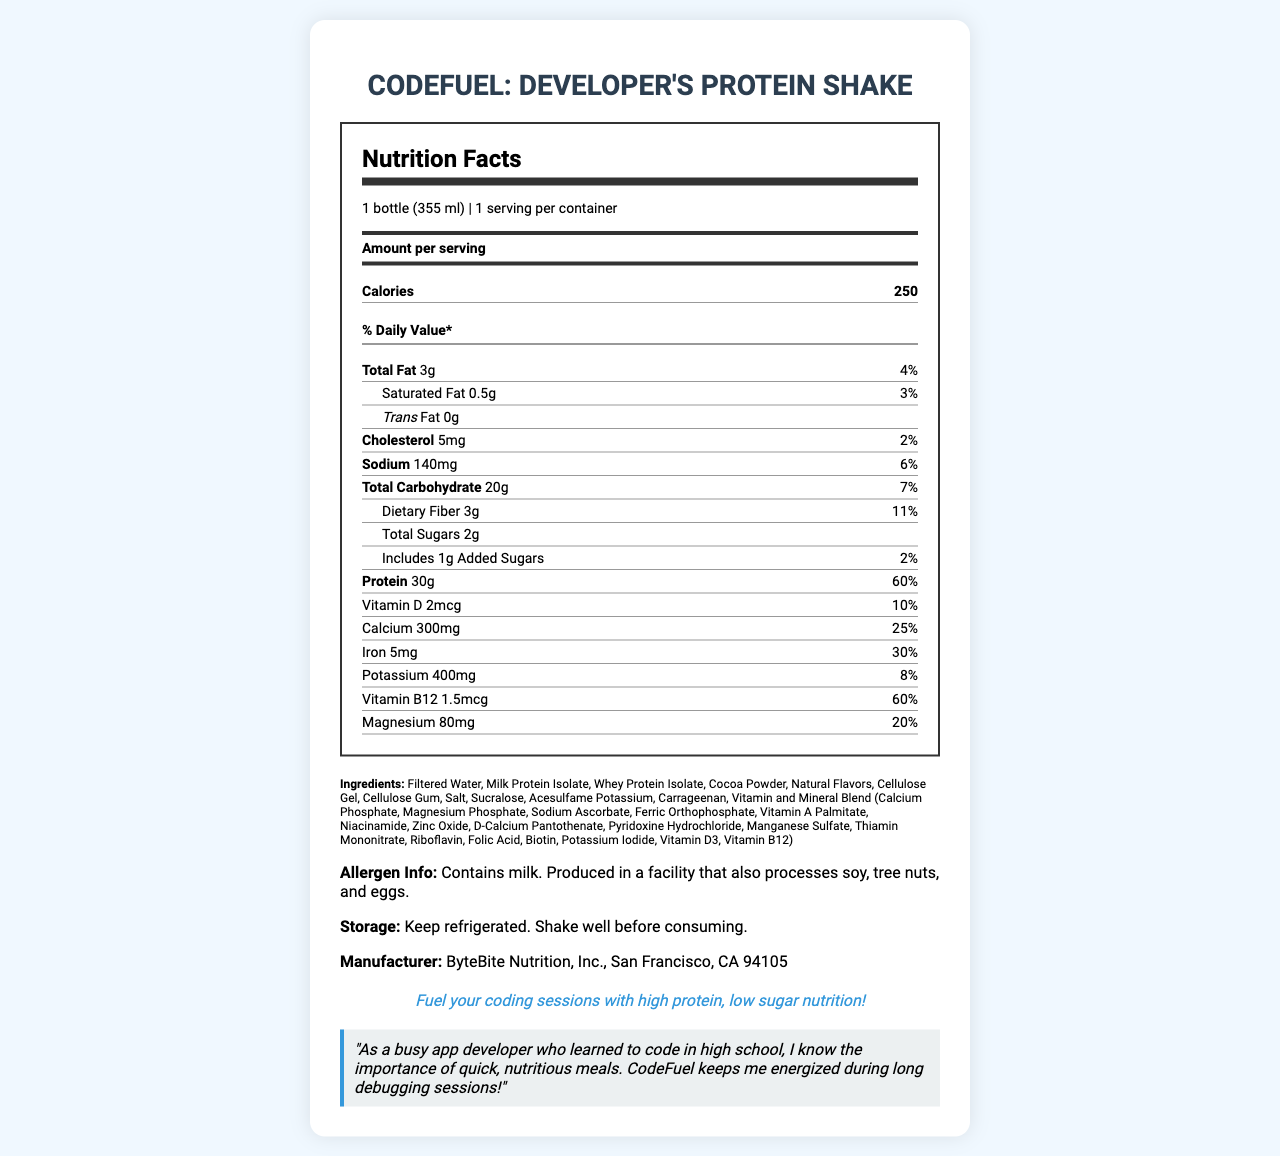what is the serving size of CodeFuel: Developer's Protein Shake? The serving size is specified as "1 bottle (355 ml)" at the top of the Nutrition Facts Label.
Answer: 1 bottle (355 ml) how many grams of protein are there per serving? The nutrition label lists "Protein 30g" under the protein section.
Answer: 30g how much calcium is in each serving? The nutrition label notes "Calcium 300mg" with a daily value percentage of "25%" under the nutrients section.
Answer: 300mg (25% DV) what is the amount of total sugars per serving? The total sugars amount is listed as "2g" in the nutrition label.
Answer: 2g what amount of dietary fiber does each serving contain? The nutrition label shows "Dietary Fiber 3g" with a daily value of "11%".
Answer: 3g (11% DV) which vitamin has the highest daily value percentage in CodeFuel? A. Vitamin D, B. Calcium, C. Iron, D. Vitamin B12 Vitamin B12 has a daily value percentage of "60%", the highest listed on the nutrition label.
Answer: D. Vitamin B12 how many calories are there in one serving? A. 200, B. 250, C. 300, D. 350 The document precisely indicates there are "250" calories in one serving.
Answer: B. 250 is the product free of trans fat? The label indicates "Trans Fat 0g", confirming that the product is free of trans fat.
Answer: Yes summarize the main idea of the document The document provides detailed information on the nutritional content and benefits intended for developers, highlighting the convenience and health advantages of the product.
Answer: The document is a Nutrition Facts Label for "CodeFuel: Developer's Protein Shake", a meal replacement shake featuring high protein (30g) and low sugar (2g) content, tailored to support busy app developers. It lists nutritional information, ingredients, allergen warnings, storage instructions, and a testimonial emphasizing its suitability for maintaining energy levels during long coding sessions. how long has the company been manufacturing this shake? The document does not provide any information about the duration or history of the product's manufacturing.
Answer: Cannot be determined 